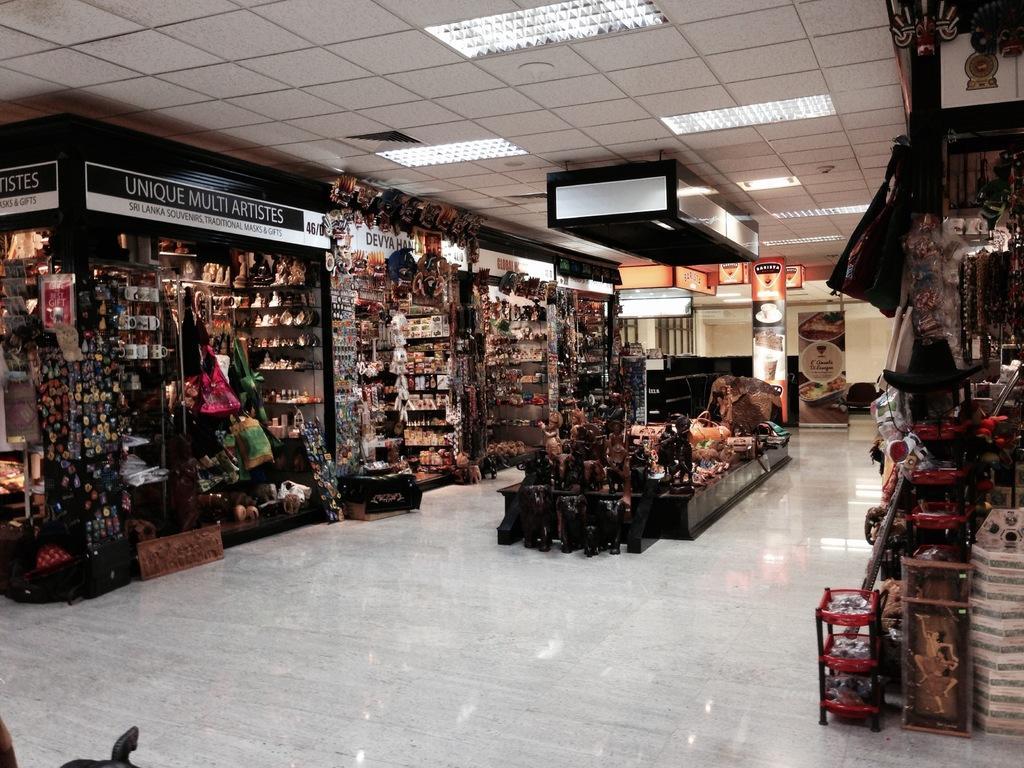How would you summarize this image in a sentence or two? In this picture we can see some shops are placed in one building. 